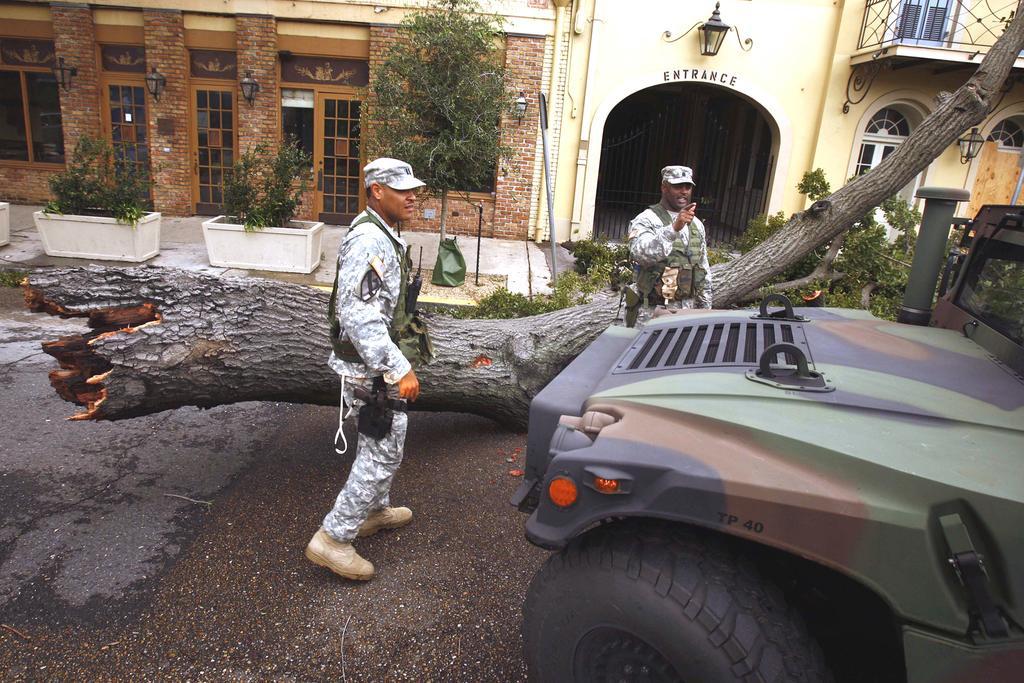Please provide a concise description of this image. This picture is clicked outside. On the right corner we can see a vehicle parked on the ground. In the center we can see the two persons wearing uniforms and seems to be walking on the ground and there is a trunk of a tree lying on the ground. In the background we can see the buildings and we can see the windows, deck rail, potted plants, metal rods, lamps and we can see the doors and the text on the building. 